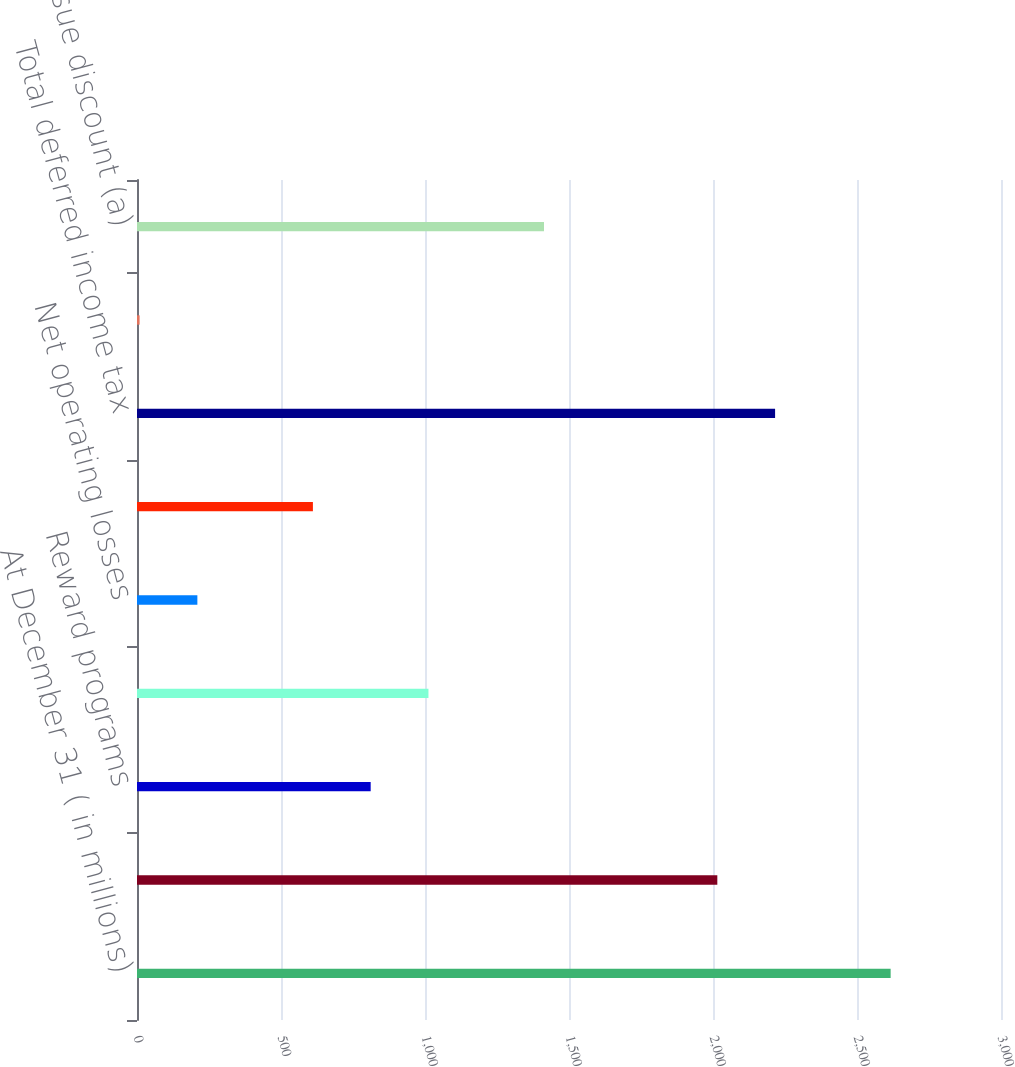Convert chart to OTSL. <chart><loc_0><loc_0><loc_500><loc_500><bar_chart><fcel>At December 31 ( in millions)<fcel>Allowance for loan losses<fcel>Reward programs<fcel>Compensation and employee<fcel>Net operating losses<fcel>Other assets<fcel>Total deferred income tax<fcel>Valuation allowance<fcel>Original issue discount (a)<nl><fcel>2616.8<fcel>2015<fcel>811.4<fcel>1012<fcel>209.6<fcel>610.8<fcel>2215.6<fcel>9<fcel>1413.2<nl></chart> 